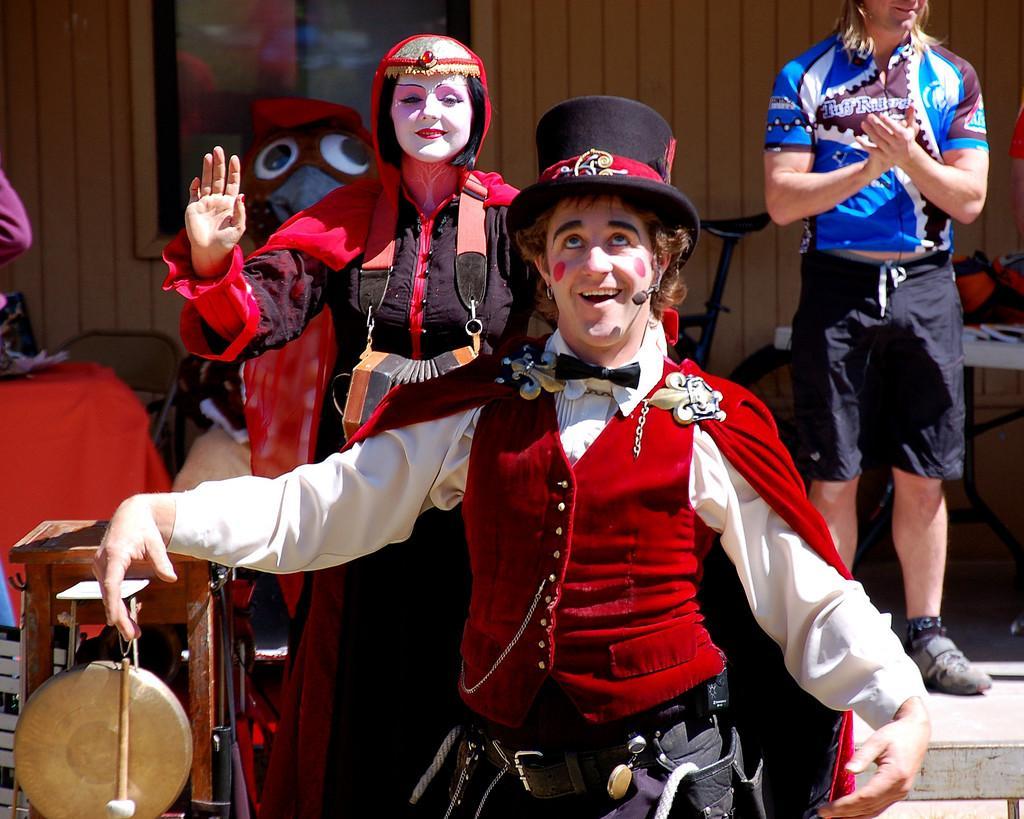In one or two sentences, can you explain what this image depicts? In the center of the image we can see persons with costumes standing on the ground. In the background we can see persons, toy, bicycle, house and window. 